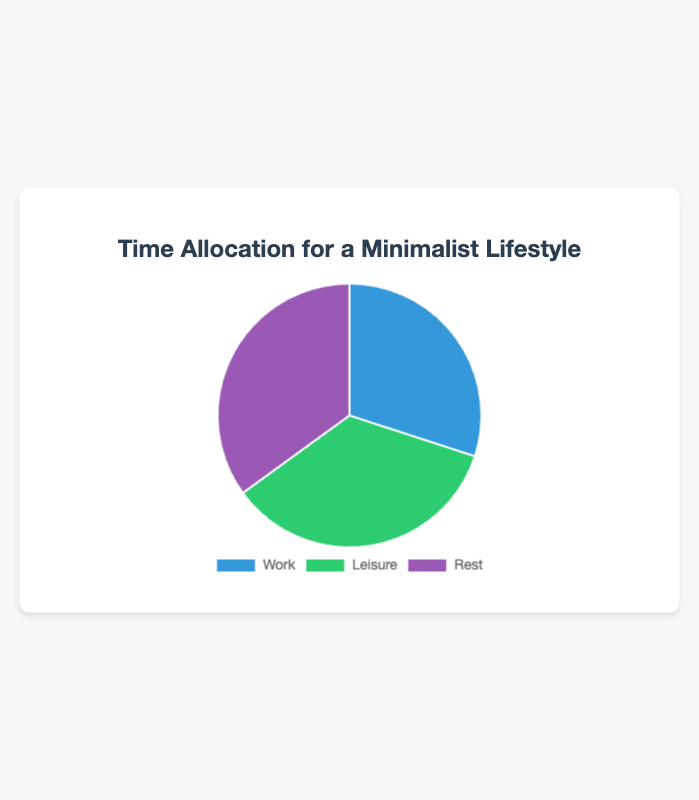Which activity occupies the largest portion of the pie chart? By examining the figure, it is clear that both Leisure and Rest occupy the largest portion of the pie chart, each with an equal share.
Answer: Leisure and Rest What is the combined percentage of time allocated to Leisure and Rest? From the figure, Leisure is 35% and Rest is also 35%. By adding these percentages together: 35% + 35% = 70%.
Answer: 70% By how much percentage does Leisure exceed Work? Leisure occupies 35% while Work occupies 30%. The difference is calculated by subtracting Work’s percentage from Leisure's: 35% - 30% = 5%.
Answer: 5% What is the difference in percentage between the smallest and largest segments? The smallest segment is Work at 30%, and the largest segments are both Leisure and Rest at 35%. The difference is 35% - 30% = 5%.
Answer: 5% Which color in the pie chart represents the Work activity? The Work activity is represented by the blue segment, as indicated by the color key and the size of the segment.
Answer: Blue If 10 more percentage points were added to Work, what would be the new percentage allocation for Work? Work currently has 30%. Adding 10 percentage points would increase it to 30% + 10% = 40%.
Answer: 40% What is the average percentage time allocated per activity? The percentages for Work, Leisure, and Rest are 30%, 35%, and 35%, respectively. Summing these percentages gives 30% + 35% + 35% = 100%. Dividing by the number of activities (3) yields an average: 100% / 3 = 33.33%.
Answer: 33.33% Identify the two activities that have the same percentage allocation in the pie chart. By inspecting the figure, we see that both Leisure and Rest share the same percentage allocation, each having 35%.
Answer: Leisure and Rest 